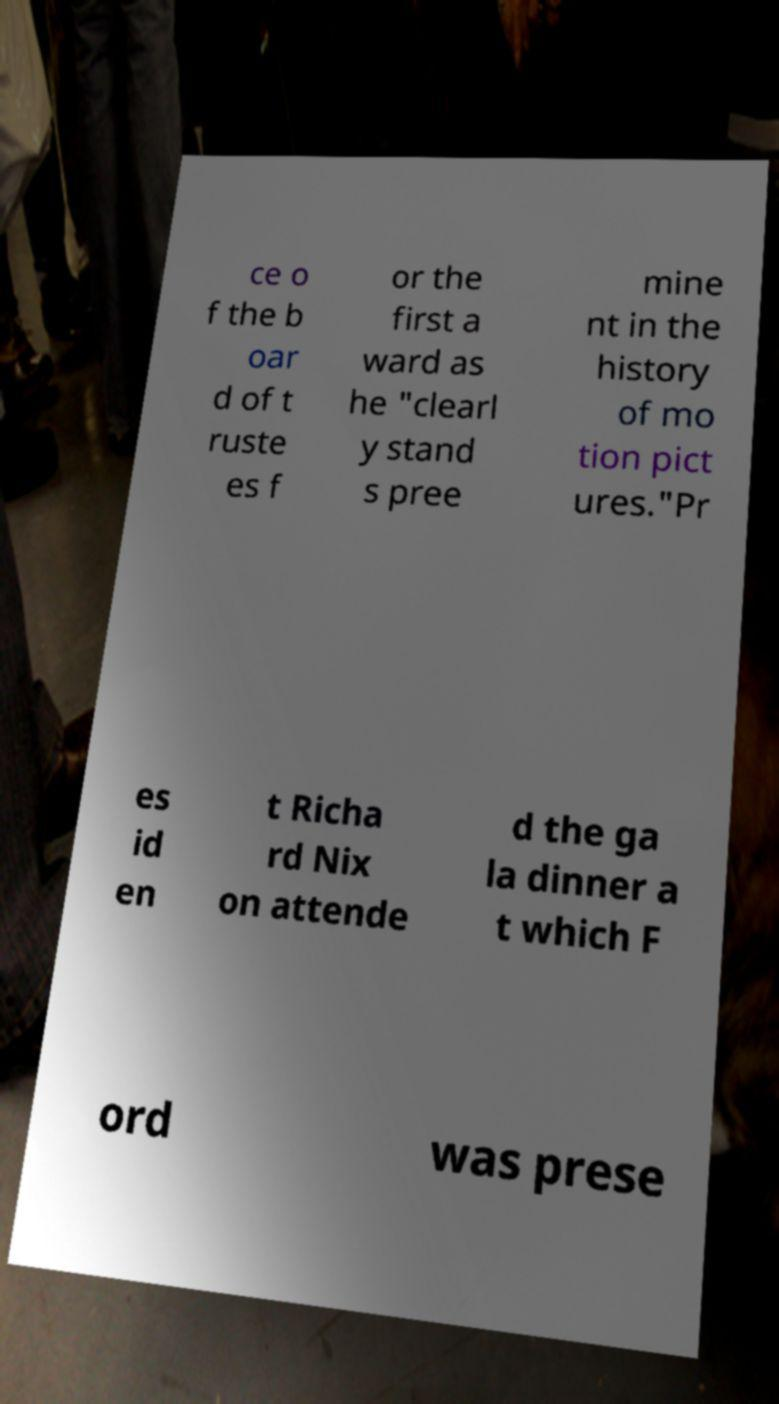For documentation purposes, I need the text within this image transcribed. Could you provide that? ce o f the b oar d of t ruste es f or the first a ward as he "clearl y stand s pree mine nt in the history of mo tion pict ures."Pr es id en t Richa rd Nix on attende d the ga la dinner a t which F ord was prese 